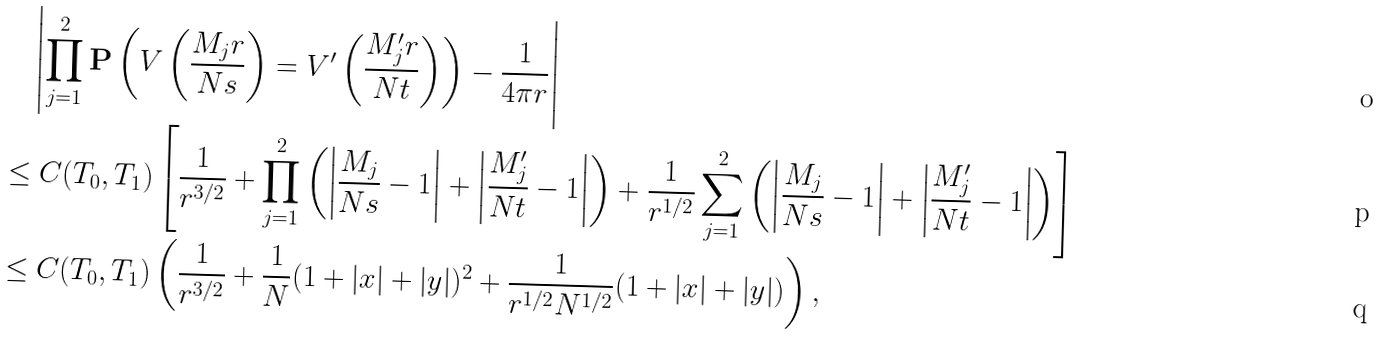<formula> <loc_0><loc_0><loc_500><loc_500>& \quad \left | \prod _ { j = 1 } ^ { 2 } \mathbf P \left ( V \left ( \frac { M _ { j } r } { N s } \right ) = V ^ { \prime } \left ( \frac { M _ { j } ^ { \prime } r } { N t } \right ) \right ) - \frac { 1 } { 4 \pi r } \right | \\ & \leq C ( T _ { 0 } , T _ { 1 } ) \left [ \frac { 1 } { r ^ { 3 / 2 } } + \prod _ { j = 1 } ^ { 2 } \left ( \left | \frac { M _ { j } } { N s } - 1 \right | + \left | \frac { M _ { j } ^ { \prime } } { N t } - 1 \right | \right ) + \frac { 1 } { r ^ { 1 / 2 } } \sum _ { j = 1 } ^ { 2 } \left ( \left | \frac { M _ { j } } { N s } - 1 \right | + \left | \frac { M _ { j } ^ { \prime } } { N t } - 1 \right | \right ) \right ] \\ & \leq C ( T _ { 0 } , T _ { 1 } ) \left ( \frac { 1 } { r ^ { 3 / 2 } } + \frac { 1 } { N } ( 1 + | x | + | y | ) ^ { 2 } + \frac { 1 } { r ^ { 1 / 2 } N ^ { 1 / 2 } } ( 1 + | x | + | y | ) \right ) ,</formula> 